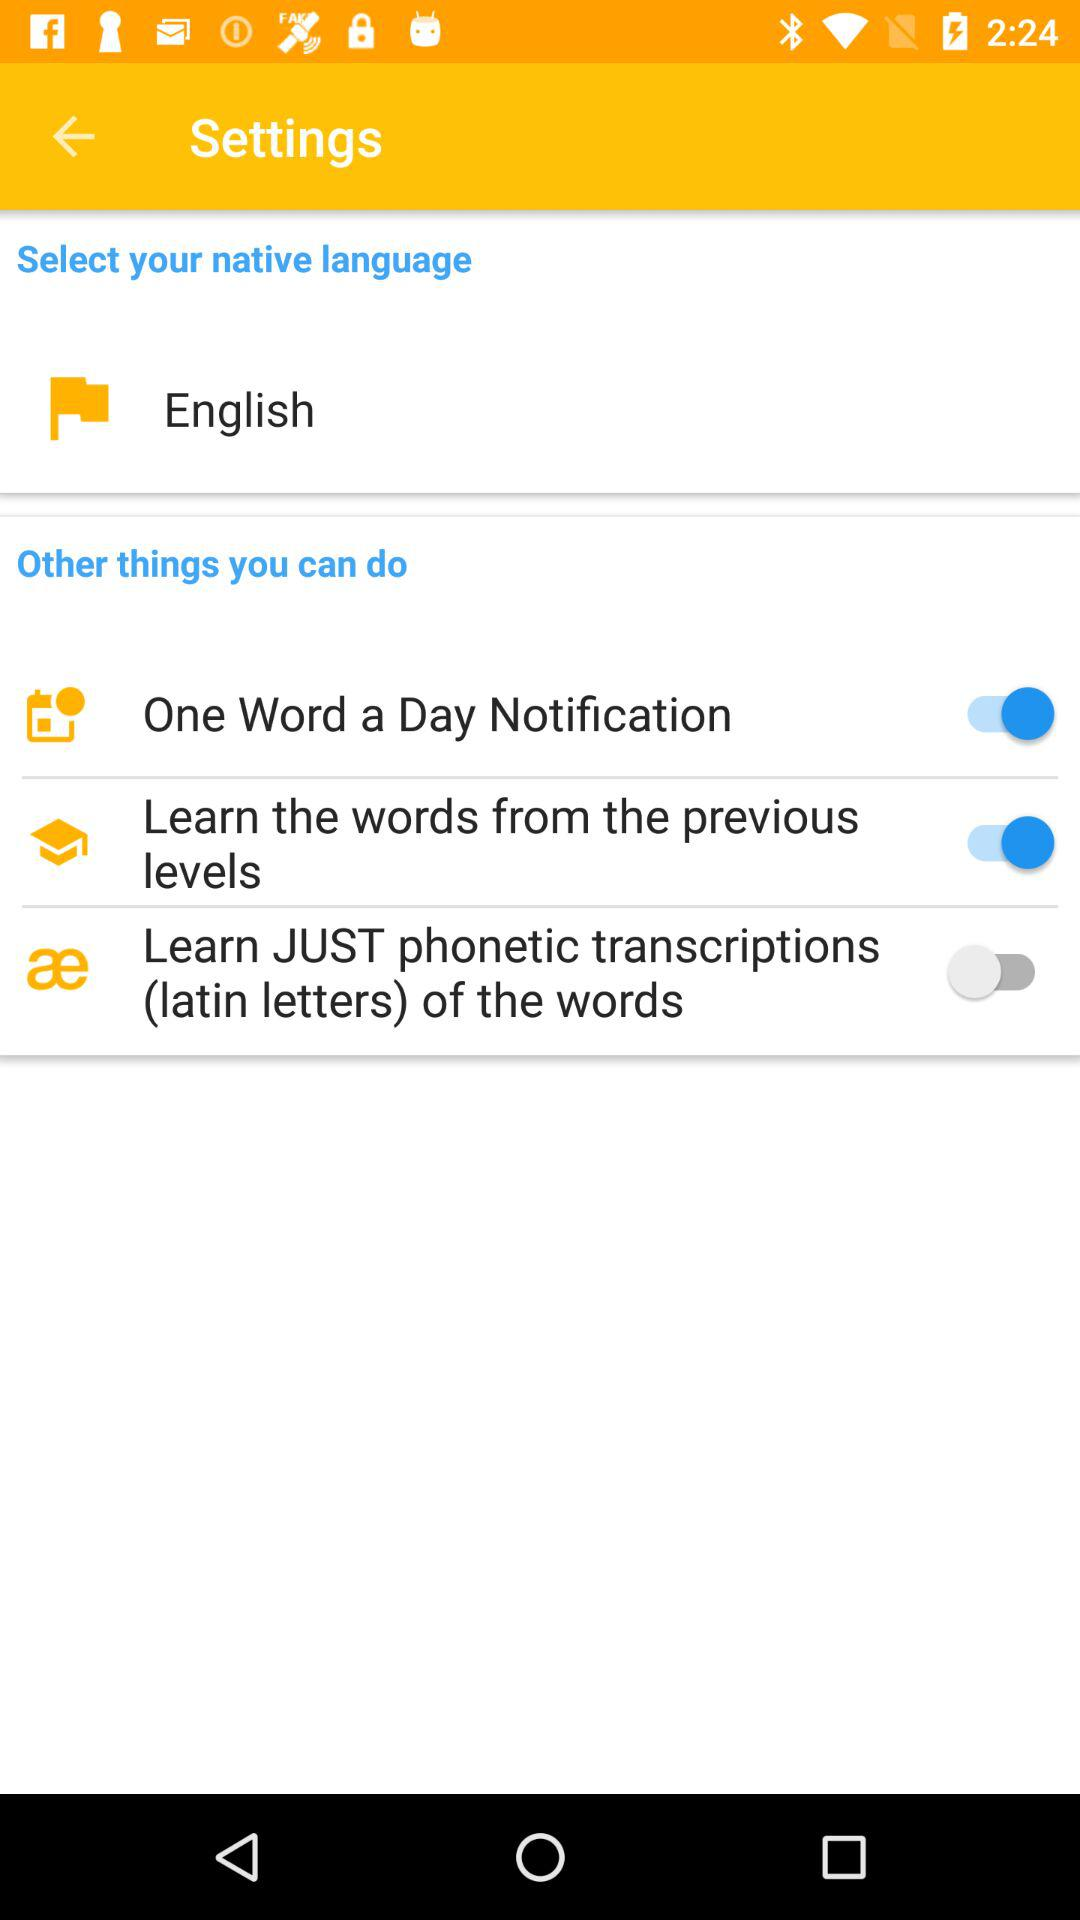Which language is selected? The selected language is English. 